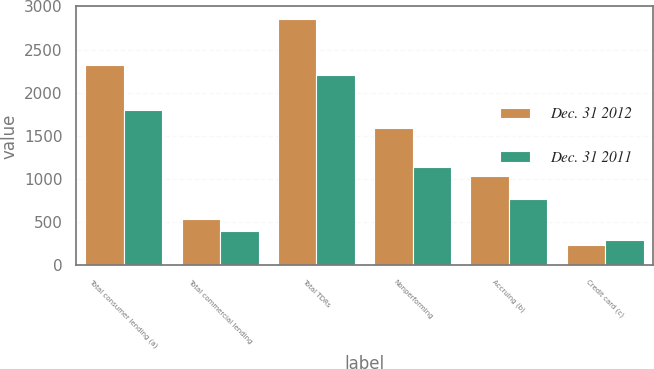Convert chart. <chart><loc_0><loc_0><loc_500><loc_500><stacked_bar_chart><ecel><fcel>Total consumer lending (a)<fcel>Total commercial lending<fcel>Total TDRs<fcel>Nonperforming<fcel>Accruing (b)<fcel>Credit card (c)<nl><fcel>Dec. 31 2012<fcel>2318<fcel>541<fcel>2859<fcel>1589<fcel>1037<fcel>233<nl><fcel>Dec. 31 2011<fcel>1798<fcel>405<fcel>2203<fcel>1141<fcel>771<fcel>291<nl></chart> 